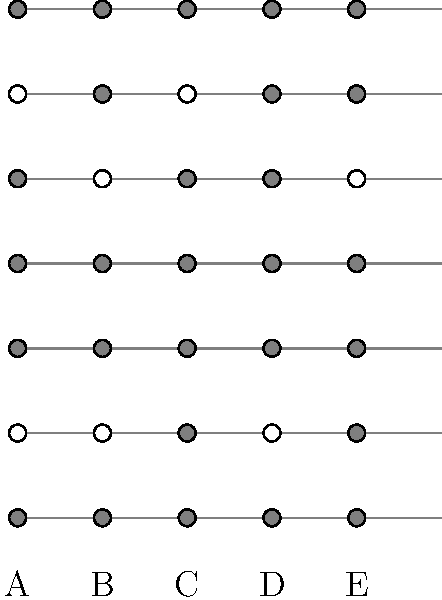The image shows five different fingering positions (A, B, C, D, E) for a clarinet. Each position can be represented as a permutation of the standard fingering (A). If we consider these fingerings as elements of a permutation group, what is the order of the subgroup generated by the permutations corresponding to positions B and D? Let's approach this step-by-step:

1) First, we need to represent each fingering as a permutation relative to the standard fingering A.

   A: (1)(2)(3)(4)(5)(6)(7) (identity permutation)
   B: (1)(2)(3)(4)(5,6)(7)
   C: (1)(2,3)(4)(5)(6)(7)
   D: (1)(2)(3)(4)(5,6,7)
   E: (1)(2,3,4)(5)(6)(7)

2) We're focusing on the subgroup generated by B and D.

3) Let's compose B and D:
   BD = (1)(2)(3)(4)(5,6)(7) * (1)(2)(3)(4)(5,6,7) = (1)(2)(3)(4)(5,7,6)

4) Now, let's continue generating elements:
   D^2 = (1)(2)(3)(4)(5,7,6)
   D^3 = (1)(2)(3)(4)(5)(6)(7) (identity)

   BD = D^2
   B^2 = (1)(2)(3)(4)(5)(6)(7) (identity)

5) We can see that all elements generated by B and D can be represented by powers of D:
   Identity, D, D^2

6) Therefore, the subgroup generated by B and D is cyclic of order 3.
Answer: 3 